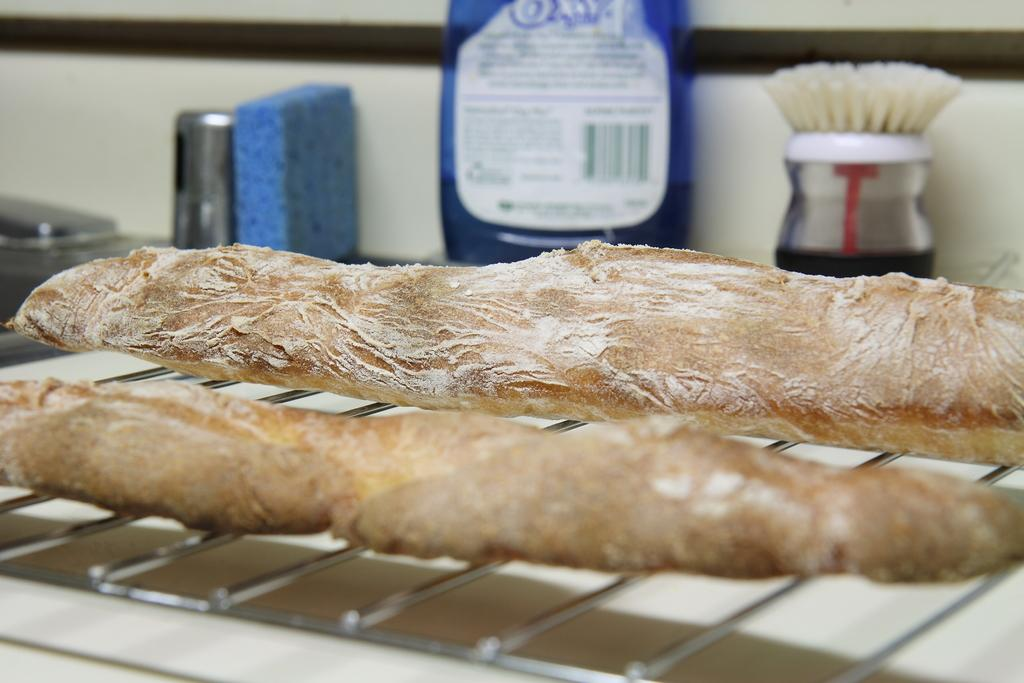What type of food is shown in the image? There are two bread pieces in the image. How are the bread pieces arranged or displayed? The bread pieces are kept on a stand. What other objects can be seen in the image besides the bread? There is a bottle and a brush visible in the image. How many geese are sitting on the plate in the image? There are no geese or plates present in the image. What type of wash is being performed on the bread in the image? There is no wash being performed on the bread in the image; the brush is likely used for another purpose, such as applying butter or spread. 